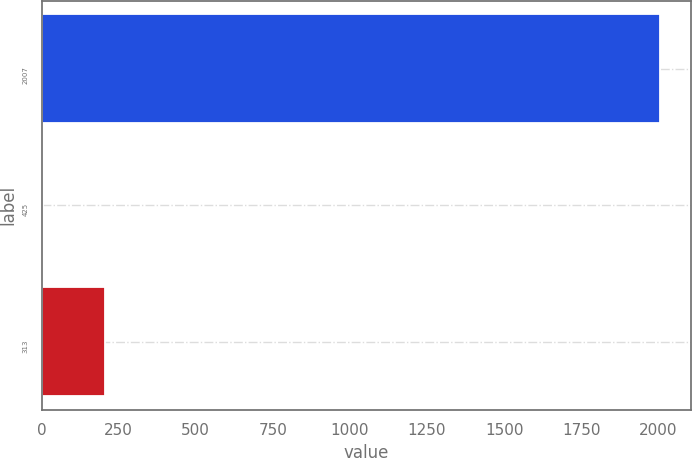Convert chart. <chart><loc_0><loc_0><loc_500><loc_500><bar_chart><fcel>2007<fcel>425<fcel>313<nl><fcel>2007<fcel>4.67<fcel>204.9<nl></chart> 